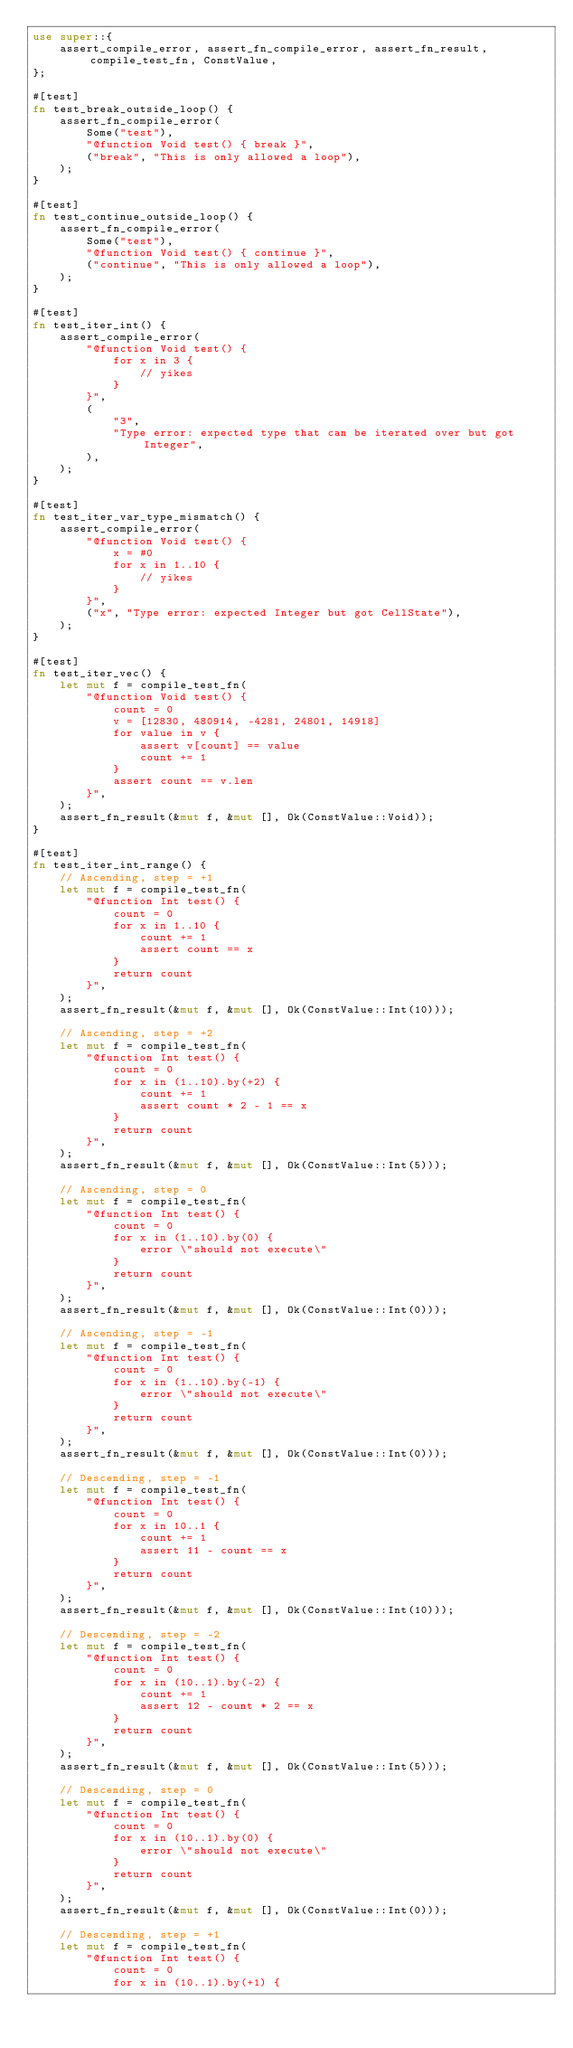Convert code to text. <code><loc_0><loc_0><loc_500><loc_500><_Rust_>use super::{
    assert_compile_error, assert_fn_compile_error, assert_fn_result, compile_test_fn, ConstValue,
};

#[test]
fn test_break_outside_loop() {
    assert_fn_compile_error(
        Some("test"),
        "@function Void test() { break }",
        ("break", "This is only allowed a loop"),
    );
}

#[test]
fn test_continue_outside_loop() {
    assert_fn_compile_error(
        Some("test"),
        "@function Void test() { continue }",
        ("continue", "This is only allowed a loop"),
    );
}

#[test]
fn test_iter_int() {
    assert_compile_error(
        "@function Void test() {
            for x in 3 {
                // yikes
            }
        }",
        (
            "3",
            "Type error: expected type that can be iterated over but got Integer",
        ),
    );
}

#[test]
fn test_iter_var_type_mismatch() {
    assert_compile_error(
        "@function Void test() {
            x = #0
            for x in 1..10 {
                // yikes
            }
        }",
        ("x", "Type error: expected Integer but got CellState"),
    );
}

#[test]
fn test_iter_vec() {
    let mut f = compile_test_fn(
        "@function Void test() {
            count = 0
            v = [12830, 480914, -4281, 24801, 14918]
            for value in v {
                assert v[count] == value
                count += 1
            }
            assert count == v.len
        }",
    );
    assert_fn_result(&mut f, &mut [], Ok(ConstValue::Void));
}

#[test]
fn test_iter_int_range() {
    // Ascending, step = +1
    let mut f = compile_test_fn(
        "@function Int test() {
            count = 0
            for x in 1..10 {
                count += 1
                assert count == x
            }
            return count
        }",
    );
    assert_fn_result(&mut f, &mut [], Ok(ConstValue::Int(10)));

    // Ascending, step = +2
    let mut f = compile_test_fn(
        "@function Int test() {
            count = 0
            for x in (1..10).by(+2) {
                count += 1
                assert count * 2 - 1 == x
            }
            return count
        }",
    );
    assert_fn_result(&mut f, &mut [], Ok(ConstValue::Int(5)));

    // Ascending, step = 0
    let mut f = compile_test_fn(
        "@function Int test() {
            count = 0
            for x in (1..10).by(0) {
                error \"should not execute\"
            }
            return count
        }",
    );
    assert_fn_result(&mut f, &mut [], Ok(ConstValue::Int(0)));

    // Ascending, step = -1
    let mut f = compile_test_fn(
        "@function Int test() {
            count = 0
            for x in (1..10).by(-1) {
                error \"should not execute\"
            }
            return count
        }",
    );
    assert_fn_result(&mut f, &mut [], Ok(ConstValue::Int(0)));

    // Descending, step = -1
    let mut f = compile_test_fn(
        "@function Int test() {
            count = 0
            for x in 10..1 {
                count += 1
                assert 11 - count == x
            }
            return count
        }",
    );
    assert_fn_result(&mut f, &mut [], Ok(ConstValue::Int(10)));

    // Descending, step = -2
    let mut f = compile_test_fn(
        "@function Int test() {
            count = 0
            for x in (10..1).by(-2) {
                count += 1
                assert 12 - count * 2 == x
            }
            return count
        }",
    );
    assert_fn_result(&mut f, &mut [], Ok(ConstValue::Int(5)));

    // Descending, step = 0
    let mut f = compile_test_fn(
        "@function Int test() {
            count = 0
            for x in (10..1).by(0) {
                error \"should not execute\"
            }
            return count
        }",
    );
    assert_fn_result(&mut f, &mut [], Ok(ConstValue::Int(0)));

    // Descending, step = +1
    let mut f = compile_test_fn(
        "@function Int test() {
            count = 0
            for x in (10..1).by(+1) {</code> 